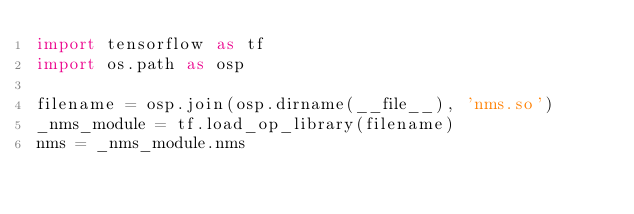<code> <loc_0><loc_0><loc_500><loc_500><_Python_>import tensorflow as tf
import os.path as osp

filename = osp.join(osp.dirname(__file__), 'nms.so')
_nms_module = tf.load_op_library(filename)
nms = _nms_module.nms
</code> 